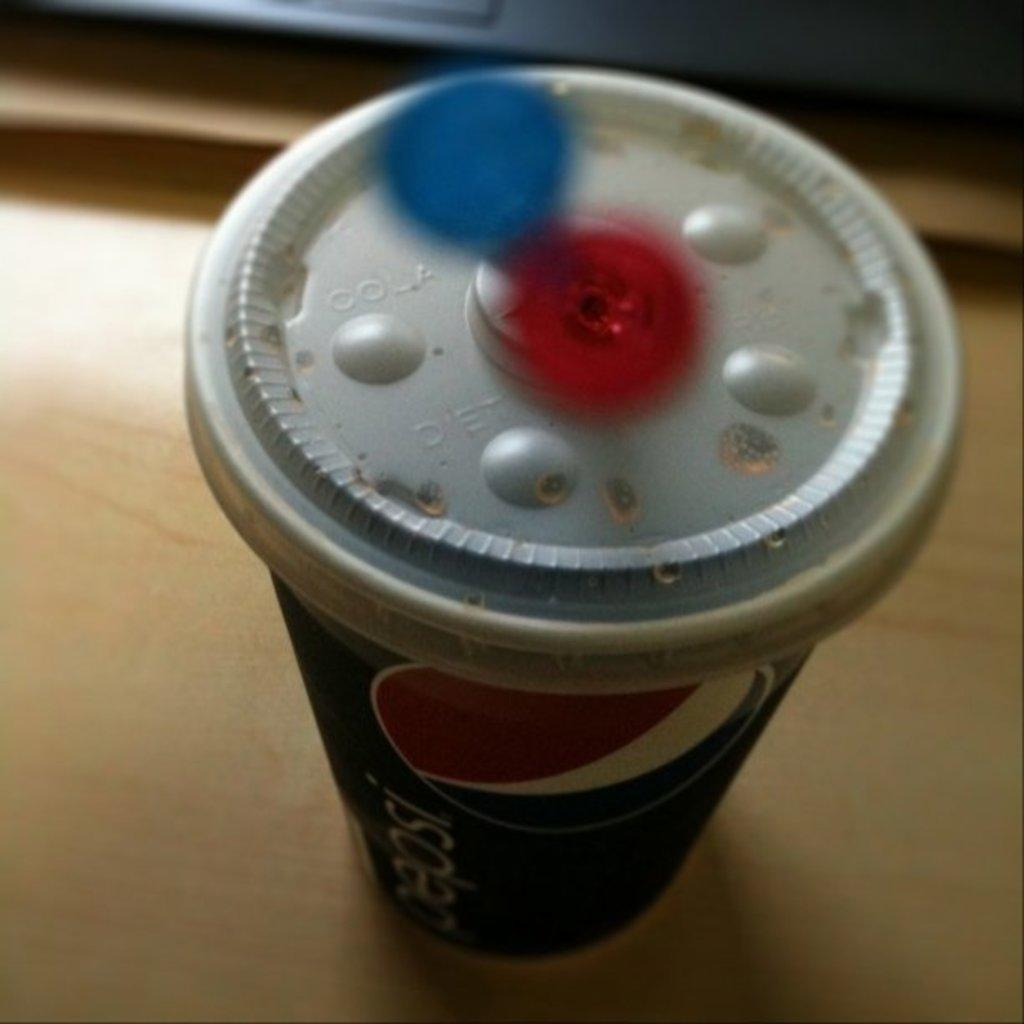<image>
Summarize the visual content of the image. A cup of soda says Pepsi on the side. 